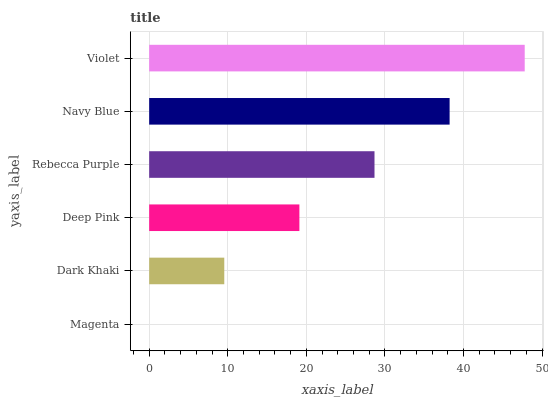Is Magenta the minimum?
Answer yes or no. Yes. Is Violet the maximum?
Answer yes or no. Yes. Is Dark Khaki the minimum?
Answer yes or no. No. Is Dark Khaki the maximum?
Answer yes or no. No. Is Dark Khaki greater than Magenta?
Answer yes or no. Yes. Is Magenta less than Dark Khaki?
Answer yes or no. Yes. Is Magenta greater than Dark Khaki?
Answer yes or no. No. Is Dark Khaki less than Magenta?
Answer yes or no. No. Is Rebecca Purple the high median?
Answer yes or no. Yes. Is Deep Pink the low median?
Answer yes or no. Yes. Is Magenta the high median?
Answer yes or no. No. Is Magenta the low median?
Answer yes or no. No. 